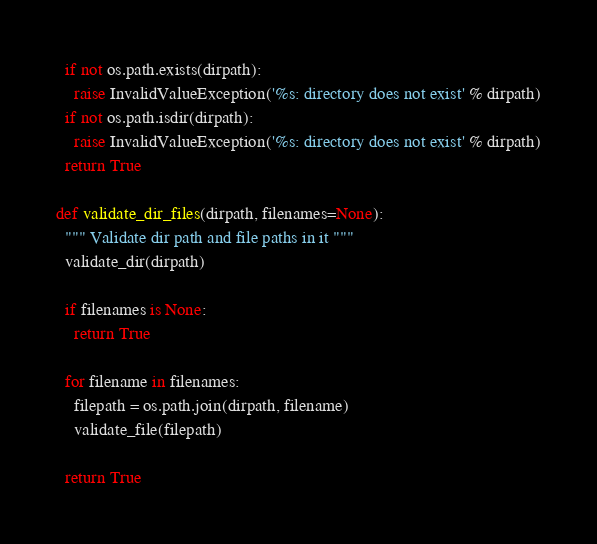Convert code to text. <code><loc_0><loc_0><loc_500><loc_500><_Python_>  if not os.path.exists(dirpath):
    raise InvalidValueException('%s: directory does not exist' % dirpath)
  if not os.path.isdir(dirpath):
    raise InvalidValueException('%s: directory does not exist' % dirpath)
  return True

def validate_dir_files(dirpath, filenames=None):
  """ Validate dir path and file paths in it """
  validate_dir(dirpath)

  if filenames is None:
    return True

  for filename in filenames:
    filepath = os.path.join(dirpath, filename)
    validate_file(filepath)

  return True
</code> 